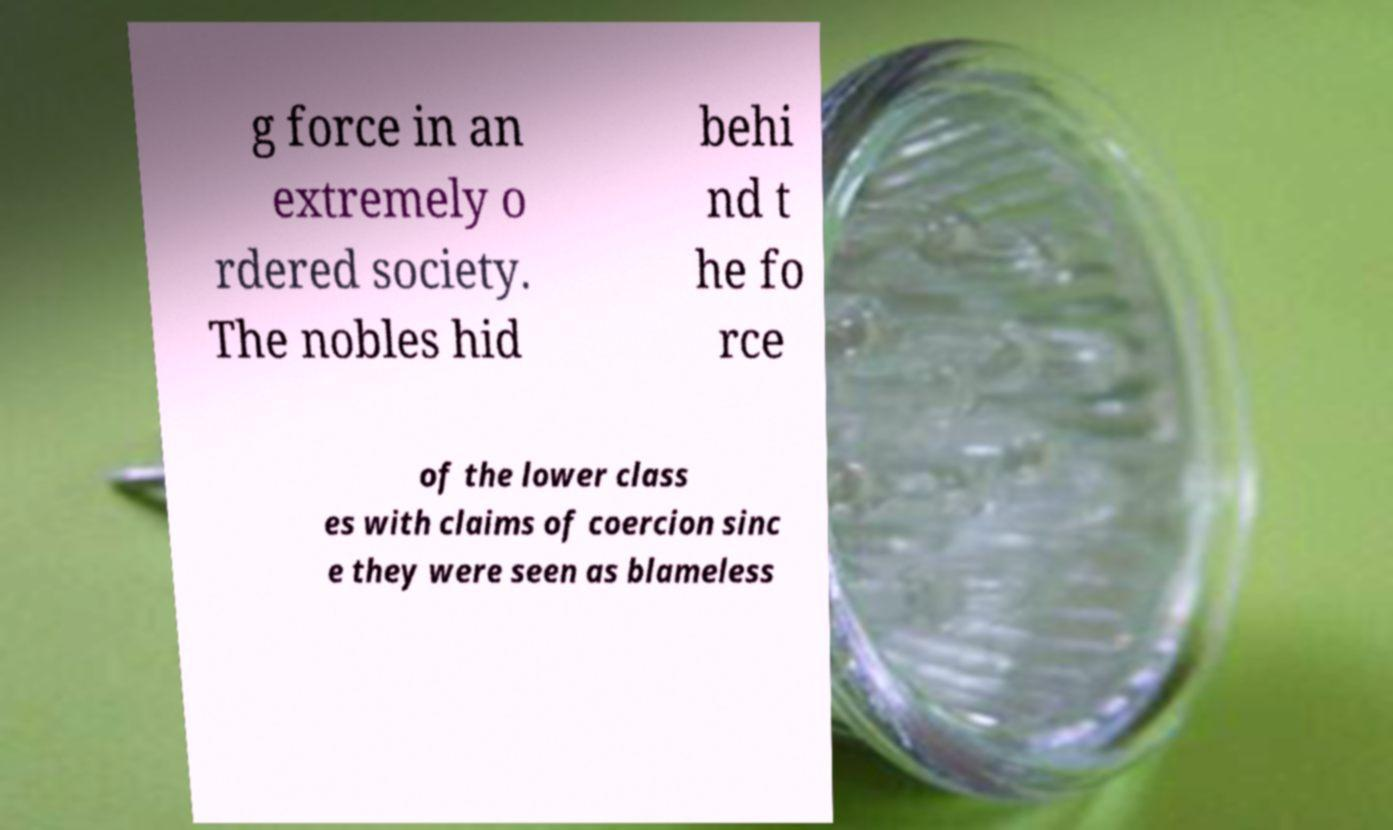Could you extract and type out the text from this image? g force in an extremely o rdered society. The nobles hid behi nd t he fo rce of the lower class es with claims of coercion sinc e they were seen as blameless 